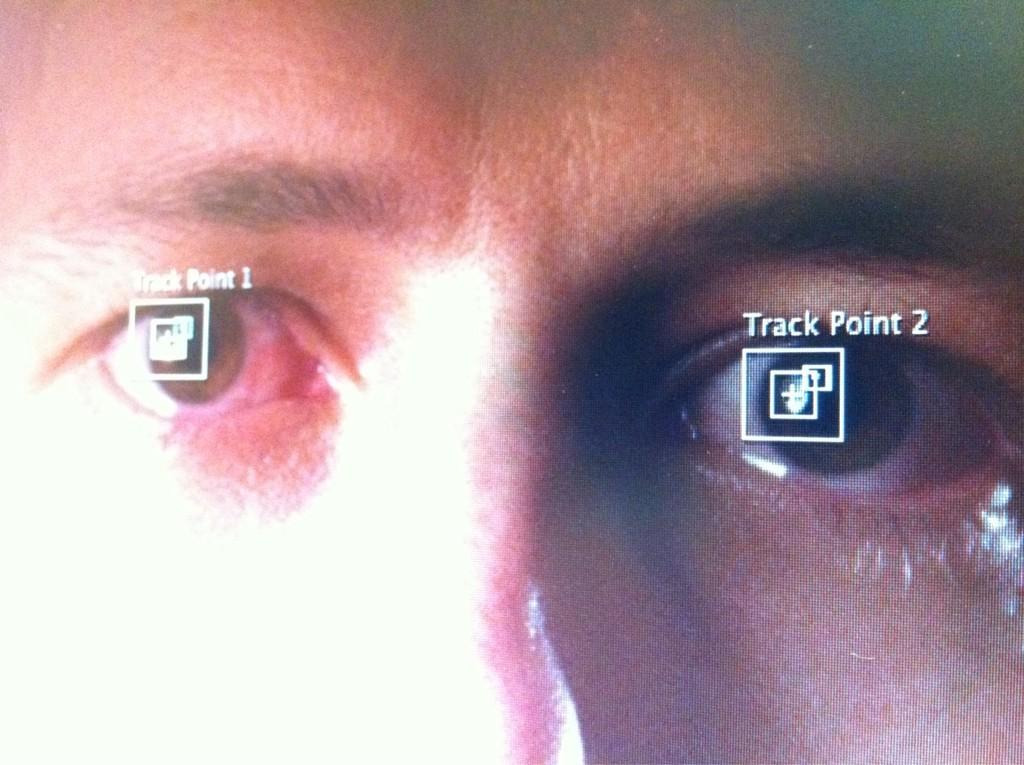What is the main object in the image? There is a screen in the image. What is shown on the screen? The screen displays a person's image. What is unique about the person's eyes in the image? There are images and text on the person's eyes in the image. How many snails can be seen crawling on the person's leg in the image? There are no snails or legs present in the image; it only features a screen with a person's image and text on their eyes. 